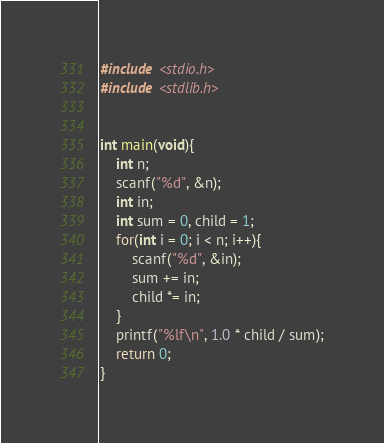Convert code to text. <code><loc_0><loc_0><loc_500><loc_500><_C_>#include <stdio.h>
#include <stdlib.h>


int main(void){
	int n;
	scanf("%d", &n);
	int in;
	int sum = 0, child = 1;
	for(int i = 0; i < n; i++){
		scanf("%d", &in);
		sum += in;
		child *= in;
	}
	printf("%lf\n", 1.0 * child / sum);
	return 0;
}
</code> 